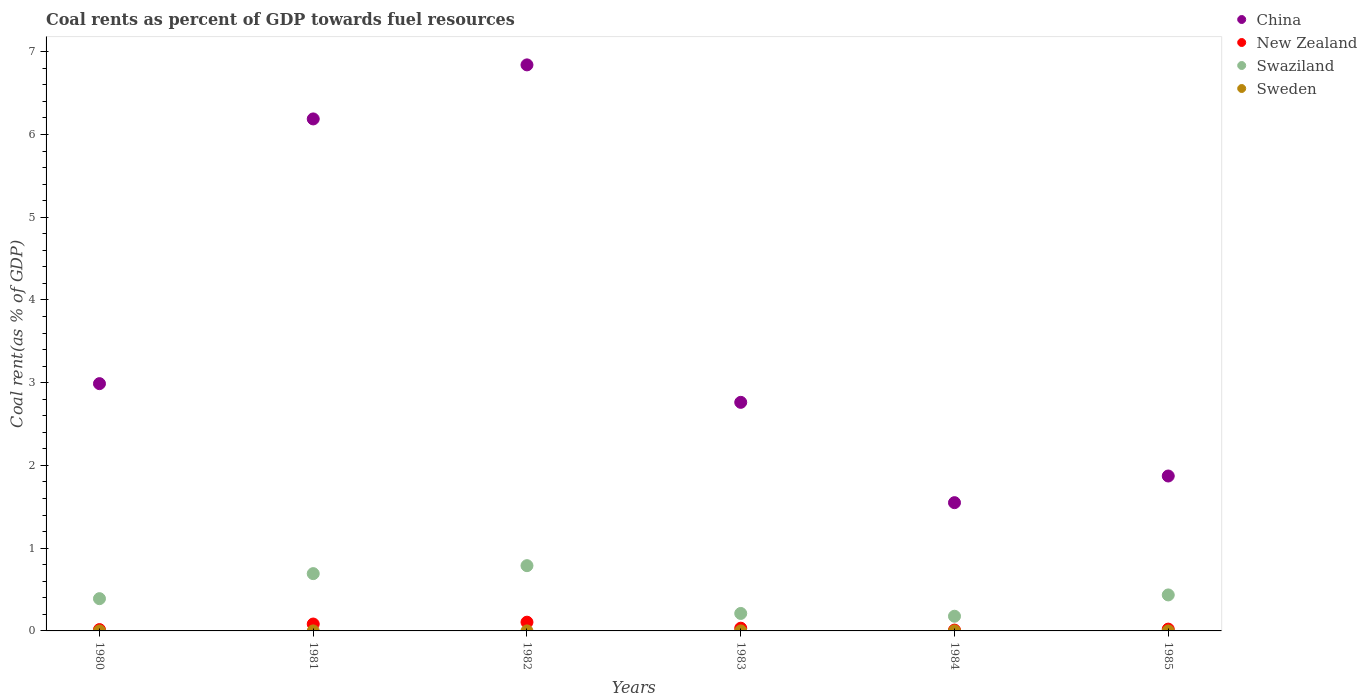Is the number of dotlines equal to the number of legend labels?
Give a very brief answer. Yes. What is the coal rent in Swaziland in 1984?
Your response must be concise. 0.18. Across all years, what is the maximum coal rent in New Zealand?
Your response must be concise. 0.11. Across all years, what is the minimum coal rent in New Zealand?
Keep it short and to the point. 0.01. In which year was the coal rent in New Zealand maximum?
Ensure brevity in your answer.  1982. What is the total coal rent in China in the graph?
Your answer should be compact. 22.2. What is the difference between the coal rent in China in 1983 and that in 1985?
Provide a succinct answer. 0.89. What is the difference between the coal rent in New Zealand in 1984 and the coal rent in Sweden in 1981?
Offer a terse response. 0.01. What is the average coal rent in China per year?
Your answer should be very brief. 3.7. In the year 1984, what is the difference between the coal rent in New Zealand and coal rent in Sweden?
Make the answer very short. 0.01. What is the ratio of the coal rent in Swaziland in 1981 to that in 1983?
Keep it short and to the point. 3.28. What is the difference between the highest and the second highest coal rent in New Zealand?
Ensure brevity in your answer.  0.02. What is the difference between the highest and the lowest coal rent in Swaziland?
Offer a terse response. 0.61. Does the coal rent in Swaziland monotonically increase over the years?
Ensure brevity in your answer.  No. How many years are there in the graph?
Provide a short and direct response. 6. Are the values on the major ticks of Y-axis written in scientific E-notation?
Your answer should be compact. No. Does the graph contain grids?
Offer a very short reply. No. Where does the legend appear in the graph?
Keep it short and to the point. Top right. What is the title of the graph?
Ensure brevity in your answer.  Coal rents as percent of GDP towards fuel resources. Does "United States" appear as one of the legend labels in the graph?
Ensure brevity in your answer.  No. What is the label or title of the Y-axis?
Make the answer very short. Coal rent(as % of GDP). What is the Coal rent(as % of GDP) in China in 1980?
Your answer should be very brief. 2.99. What is the Coal rent(as % of GDP) in New Zealand in 1980?
Provide a succinct answer. 0.02. What is the Coal rent(as % of GDP) of Swaziland in 1980?
Offer a very short reply. 0.39. What is the Coal rent(as % of GDP) in Sweden in 1980?
Give a very brief answer. 3.34719228458372e-5. What is the Coal rent(as % of GDP) in China in 1981?
Your answer should be very brief. 6.19. What is the Coal rent(as % of GDP) of New Zealand in 1981?
Offer a terse response. 0.08. What is the Coal rent(as % of GDP) in Swaziland in 1981?
Offer a very short reply. 0.69. What is the Coal rent(as % of GDP) of Sweden in 1981?
Offer a very short reply. 0. What is the Coal rent(as % of GDP) in China in 1982?
Provide a succinct answer. 6.84. What is the Coal rent(as % of GDP) of New Zealand in 1982?
Keep it short and to the point. 0.11. What is the Coal rent(as % of GDP) of Swaziland in 1982?
Your answer should be compact. 0.79. What is the Coal rent(as % of GDP) in Sweden in 1982?
Your answer should be compact. 0. What is the Coal rent(as % of GDP) in China in 1983?
Give a very brief answer. 2.76. What is the Coal rent(as % of GDP) in New Zealand in 1983?
Give a very brief answer. 0.03. What is the Coal rent(as % of GDP) in Swaziland in 1983?
Give a very brief answer. 0.21. What is the Coal rent(as % of GDP) of Sweden in 1983?
Offer a very short reply. 3.24126709806877e-5. What is the Coal rent(as % of GDP) of China in 1984?
Your response must be concise. 1.55. What is the Coal rent(as % of GDP) in New Zealand in 1984?
Keep it short and to the point. 0.01. What is the Coal rent(as % of GDP) of Swaziland in 1984?
Provide a succinct answer. 0.18. What is the Coal rent(as % of GDP) of Sweden in 1984?
Ensure brevity in your answer.  1.4188022922849e-6. What is the Coal rent(as % of GDP) in China in 1985?
Provide a succinct answer. 1.87. What is the Coal rent(as % of GDP) of New Zealand in 1985?
Provide a short and direct response. 0.02. What is the Coal rent(as % of GDP) in Swaziland in 1985?
Provide a short and direct response. 0.44. What is the Coal rent(as % of GDP) of Sweden in 1985?
Your response must be concise. 1.64898213038946e-5. Across all years, what is the maximum Coal rent(as % of GDP) in China?
Your answer should be compact. 6.84. Across all years, what is the maximum Coal rent(as % of GDP) of New Zealand?
Provide a succinct answer. 0.11. Across all years, what is the maximum Coal rent(as % of GDP) of Swaziland?
Your response must be concise. 0.79. Across all years, what is the maximum Coal rent(as % of GDP) of Sweden?
Ensure brevity in your answer.  0. Across all years, what is the minimum Coal rent(as % of GDP) of China?
Your answer should be very brief. 1.55. Across all years, what is the minimum Coal rent(as % of GDP) of New Zealand?
Your response must be concise. 0.01. Across all years, what is the minimum Coal rent(as % of GDP) in Swaziland?
Offer a very short reply. 0.18. Across all years, what is the minimum Coal rent(as % of GDP) of Sweden?
Your answer should be compact. 1.4188022922849e-6. What is the total Coal rent(as % of GDP) in China in the graph?
Ensure brevity in your answer.  22.2. What is the total Coal rent(as % of GDP) in New Zealand in the graph?
Give a very brief answer. 0.27. What is the total Coal rent(as % of GDP) in Swaziland in the graph?
Your answer should be very brief. 2.69. What is the difference between the Coal rent(as % of GDP) of China in 1980 and that in 1981?
Provide a short and direct response. -3.2. What is the difference between the Coal rent(as % of GDP) of New Zealand in 1980 and that in 1981?
Offer a very short reply. -0.07. What is the difference between the Coal rent(as % of GDP) in Swaziland in 1980 and that in 1981?
Keep it short and to the point. -0.3. What is the difference between the Coal rent(as % of GDP) of Sweden in 1980 and that in 1981?
Offer a terse response. -0. What is the difference between the Coal rent(as % of GDP) in China in 1980 and that in 1982?
Ensure brevity in your answer.  -3.85. What is the difference between the Coal rent(as % of GDP) of New Zealand in 1980 and that in 1982?
Offer a very short reply. -0.09. What is the difference between the Coal rent(as % of GDP) in Swaziland in 1980 and that in 1982?
Offer a terse response. -0.4. What is the difference between the Coal rent(as % of GDP) in Sweden in 1980 and that in 1982?
Your answer should be compact. -0. What is the difference between the Coal rent(as % of GDP) in China in 1980 and that in 1983?
Give a very brief answer. 0.23. What is the difference between the Coal rent(as % of GDP) in New Zealand in 1980 and that in 1983?
Keep it short and to the point. -0.02. What is the difference between the Coal rent(as % of GDP) in Swaziland in 1980 and that in 1983?
Your answer should be compact. 0.18. What is the difference between the Coal rent(as % of GDP) of Sweden in 1980 and that in 1983?
Provide a short and direct response. 0. What is the difference between the Coal rent(as % of GDP) of China in 1980 and that in 1984?
Your answer should be compact. 1.44. What is the difference between the Coal rent(as % of GDP) in New Zealand in 1980 and that in 1984?
Keep it short and to the point. 0.01. What is the difference between the Coal rent(as % of GDP) in Swaziland in 1980 and that in 1984?
Keep it short and to the point. 0.21. What is the difference between the Coal rent(as % of GDP) of Sweden in 1980 and that in 1984?
Ensure brevity in your answer.  0. What is the difference between the Coal rent(as % of GDP) of China in 1980 and that in 1985?
Give a very brief answer. 1.12. What is the difference between the Coal rent(as % of GDP) of New Zealand in 1980 and that in 1985?
Your answer should be compact. -0.01. What is the difference between the Coal rent(as % of GDP) of Swaziland in 1980 and that in 1985?
Ensure brevity in your answer.  -0.05. What is the difference between the Coal rent(as % of GDP) in China in 1981 and that in 1982?
Ensure brevity in your answer.  -0.65. What is the difference between the Coal rent(as % of GDP) in New Zealand in 1981 and that in 1982?
Give a very brief answer. -0.02. What is the difference between the Coal rent(as % of GDP) of Swaziland in 1981 and that in 1982?
Your answer should be compact. -0.1. What is the difference between the Coal rent(as % of GDP) in China in 1981 and that in 1983?
Offer a terse response. 3.43. What is the difference between the Coal rent(as % of GDP) in New Zealand in 1981 and that in 1983?
Offer a terse response. 0.05. What is the difference between the Coal rent(as % of GDP) in Swaziland in 1981 and that in 1983?
Offer a very short reply. 0.48. What is the difference between the Coal rent(as % of GDP) in Sweden in 1981 and that in 1983?
Provide a succinct answer. 0. What is the difference between the Coal rent(as % of GDP) of China in 1981 and that in 1984?
Your response must be concise. 4.64. What is the difference between the Coal rent(as % of GDP) of New Zealand in 1981 and that in 1984?
Give a very brief answer. 0.07. What is the difference between the Coal rent(as % of GDP) of Swaziland in 1981 and that in 1984?
Make the answer very short. 0.52. What is the difference between the Coal rent(as % of GDP) of Sweden in 1981 and that in 1984?
Provide a short and direct response. 0. What is the difference between the Coal rent(as % of GDP) of China in 1981 and that in 1985?
Offer a terse response. 4.32. What is the difference between the Coal rent(as % of GDP) in New Zealand in 1981 and that in 1985?
Your response must be concise. 0.06. What is the difference between the Coal rent(as % of GDP) in Swaziland in 1981 and that in 1985?
Offer a terse response. 0.26. What is the difference between the Coal rent(as % of GDP) of Sweden in 1981 and that in 1985?
Your answer should be compact. 0. What is the difference between the Coal rent(as % of GDP) in China in 1982 and that in 1983?
Provide a succinct answer. 4.08. What is the difference between the Coal rent(as % of GDP) of New Zealand in 1982 and that in 1983?
Keep it short and to the point. 0.07. What is the difference between the Coal rent(as % of GDP) in Swaziland in 1982 and that in 1983?
Offer a terse response. 0.58. What is the difference between the Coal rent(as % of GDP) of China in 1982 and that in 1984?
Your answer should be compact. 5.29. What is the difference between the Coal rent(as % of GDP) in New Zealand in 1982 and that in 1984?
Give a very brief answer. 0.1. What is the difference between the Coal rent(as % of GDP) of Swaziland in 1982 and that in 1984?
Your answer should be very brief. 0.61. What is the difference between the Coal rent(as % of GDP) in China in 1982 and that in 1985?
Give a very brief answer. 4.97. What is the difference between the Coal rent(as % of GDP) of New Zealand in 1982 and that in 1985?
Your answer should be compact. 0.08. What is the difference between the Coal rent(as % of GDP) of Swaziland in 1982 and that in 1985?
Ensure brevity in your answer.  0.35. What is the difference between the Coal rent(as % of GDP) of Sweden in 1982 and that in 1985?
Your answer should be compact. 0. What is the difference between the Coal rent(as % of GDP) in China in 1983 and that in 1984?
Provide a short and direct response. 1.21. What is the difference between the Coal rent(as % of GDP) in New Zealand in 1983 and that in 1984?
Ensure brevity in your answer.  0.02. What is the difference between the Coal rent(as % of GDP) in Swaziland in 1983 and that in 1984?
Provide a short and direct response. 0.03. What is the difference between the Coal rent(as % of GDP) of Sweden in 1983 and that in 1984?
Offer a terse response. 0. What is the difference between the Coal rent(as % of GDP) of China in 1983 and that in 1985?
Give a very brief answer. 0.89. What is the difference between the Coal rent(as % of GDP) of New Zealand in 1983 and that in 1985?
Your answer should be compact. 0.01. What is the difference between the Coal rent(as % of GDP) of Swaziland in 1983 and that in 1985?
Make the answer very short. -0.22. What is the difference between the Coal rent(as % of GDP) of China in 1984 and that in 1985?
Offer a very short reply. -0.32. What is the difference between the Coal rent(as % of GDP) in New Zealand in 1984 and that in 1985?
Your answer should be very brief. -0.01. What is the difference between the Coal rent(as % of GDP) in Swaziland in 1984 and that in 1985?
Give a very brief answer. -0.26. What is the difference between the Coal rent(as % of GDP) in China in 1980 and the Coal rent(as % of GDP) in New Zealand in 1981?
Your answer should be compact. 2.91. What is the difference between the Coal rent(as % of GDP) of China in 1980 and the Coal rent(as % of GDP) of Swaziland in 1981?
Keep it short and to the point. 2.3. What is the difference between the Coal rent(as % of GDP) of China in 1980 and the Coal rent(as % of GDP) of Sweden in 1981?
Provide a short and direct response. 2.99. What is the difference between the Coal rent(as % of GDP) in New Zealand in 1980 and the Coal rent(as % of GDP) in Swaziland in 1981?
Keep it short and to the point. -0.68. What is the difference between the Coal rent(as % of GDP) of New Zealand in 1980 and the Coal rent(as % of GDP) of Sweden in 1981?
Your response must be concise. 0.02. What is the difference between the Coal rent(as % of GDP) in Swaziland in 1980 and the Coal rent(as % of GDP) in Sweden in 1981?
Your answer should be very brief. 0.39. What is the difference between the Coal rent(as % of GDP) of China in 1980 and the Coal rent(as % of GDP) of New Zealand in 1982?
Your response must be concise. 2.88. What is the difference between the Coal rent(as % of GDP) in China in 1980 and the Coal rent(as % of GDP) in Swaziland in 1982?
Your answer should be compact. 2.2. What is the difference between the Coal rent(as % of GDP) in China in 1980 and the Coal rent(as % of GDP) in Sweden in 1982?
Ensure brevity in your answer.  2.99. What is the difference between the Coal rent(as % of GDP) in New Zealand in 1980 and the Coal rent(as % of GDP) in Swaziland in 1982?
Give a very brief answer. -0.77. What is the difference between the Coal rent(as % of GDP) in New Zealand in 1980 and the Coal rent(as % of GDP) in Sweden in 1982?
Your response must be concise. 0.02. What is the difference between the Coal rent(as % of GDP) of Swaziland in 1980 and the Coal rent(as % of GDP) of Sweden in 1982?
Your response must be concise. 0.39. What is the difference between the Coal rent(as % of GDP) in China in 1980 and the Coal rent(as % of GDP) in New Zealand in 1983?
Provide a short and direct response. 2.96. What is the difference between the Coal rent(as % of GDP) of China in 1980 and the Coal rent(as % of GDP) of Swaziland in 1983?
Your answer should be compact. 2.78. What is the difference between the Coal rent(as % of GDP) of China in 1980 and the Coal rent(as % of GDP) of Sweden in 1983?
Make the answer very short. 2.99. What is the difference between the Coal rent(as % of GDP) of New Zealand in 1980 and the Coal rent(as % of GDP) of Swaziland in 1983?
Ensure brevity in your answer.  -0.2. What is the difference between the Coal rent(as % of GDP) in New Zealand in 1980 and the Coal rent(as % of GDP) in Sweden in 1983?
Your answer should be compact. 0.02. What is the difference between the Coal rent(as % of GDP) in Swaziland in 1980 and the Coal rent(as % of GDP) in Sweden in 1983?
Your response must be concise. 0.39. What is the difference between the Coal rent(as % of GDP) in China in 1980 and the Coal rent(as % of GDP) in New Zealand in 1984?
Make the answer very short. 2.98. What is the difference between the Coal rent(as % of GDP) of China in 1980 and the Coal rent(as % of GDP) of Swaziland in 1984?
Your response must be concise. 2.81. What is the difference between the Coal rent(as % of GDP) of China in 1980 and the Coal rent(as % of GDP) of Sweden in 1984?
Give a very brief answer. 2.99. What is the difference between the Coal rent(as % of GDP) in New Zealand in 1980 and the Coal rent(as % of GDP) in Swaziland in 1984?
Your answer should be compact. -0.16. What is the difference between the Coal rent(as % of GDP) in New Zealand in 1980 and the Coal rent(as % of GDP) in Sweden in 1984?
Give a very brief answer. 0.02. What is the difference between the Coal rent(as % of GDP) of Swaziland in 1980 and the Coal rent(as % of GDP) of Sweden in 1984?
Provide a succinct answer. 0.39. What is the difference between the Coal rent(as % of GDP) in China in 1980 and the Coal rent(as % of GDP) in New Zealand in 1985?
Ensure brevity in your answer.  2.97. What is the difference between the Coal rent(as % of GDP) in China in 1980 and the Coal rent(as % of GDP) in Swaziland in 1985?
Your response must be concise. 2.55. What is the difference between the Coal rent(as % of GDP) of China in 1980 and the Coal rent(as % of GDP) of Sweden in 1985?
Offer a terse response. 2.99. What is the difference between the Coal rent(as % of GDP) of New Zealand in 1980 and the Coal rent(as % of GDP) of Swaziland in 1985?
Keep it short and to the point. -0.42. What is the difference between the Coal rent(as % of GDP) of New Zealand in 1980 and the Coal rent(as % of GDP) of Sweden in 1985?
Keep it short and to the point. 0.02. What is the difference between the Coal rent(as % of GDP) of Swaziland in 1980 and the Coal rent(as % of GDP) of Sweden in 1985?
Give a very brief answer. 0.39. What is the difference between the Coal rent(as % of GDP) in China in 1981 and the Coal rent(as % of GDP) in New Zealand in 1982?
Make the answer very short. 6.08. What is the difference between the Coal rent(as % of GDP) in China in 1981 and the Coal rent(as % of GDP) in Swaziland in 1982?
Offer a very short reply. 5.4. What is the difference between the Coal rent(as % of GDP) of China in 1981 and the Coal rent(as % of GDP) of Sweden in 1982?
Give a very brief answer. 6.19. What is the difference between the Coal rent(as % of GDP) of New Zealand in 1981 and the Coal rent(as % of GDP) of Swaziland in 1982?
Your response must be concise. -0.71. What is the difference between the Coal rent(as % of GDP) in New Zealand in 1981 and the Coal rent(as % of GDP) in Sweden in 1982?
Make the answer very short. 0.08. What is the difference between the Coal rent(as % of GDP) in Swaziland in 1981 and the Coal rent(as % of GDP) in Sweden in 1982?
Make the answer very short. 0.69. What is the difference between the Coal rent(as % of GDP) of China in 1981 and the Coal rent(as % of GDP) of New Zealand in 1983?
Your response must be concise. 6.15. What is the difference between the Coal rent(as % of GDP) of China in 1981 and the Coal rent(as % of GDP) of Swaziland in 1983?
Ensure brevity in your answer.  5.98. What is the difference between the Coal rent(as % of GDP) in China in 1981 and the Coal rent(as % of GDP) in Sweden in 1983?
Ensure brevity in your answer.  6.19. What is the difference between the Coal rent(as % of GDP) in New Zealand in 1981 and the Coal rent(as % of GDP) in Swaziland in 1983?
Offer a terse response. -0.13. What is the difference between the Coal rent(as % of GDP) of New Zealand in 1981 and the Coal rent(as % of GDP) of Sweden in 1983?
Your answer should be compact. 0.08. What is the difference between the Coal rent(as % of GDP) of Swaziland in 1981 and the Coal rent(as % of GDP) of Sweden in 1983?
Keep it short and to the point. 0.69. What is the difference between the Coal rent(as % of GDP) in China in 1981 and the Coal rent(as % of GDP) in New Zealand in 1984?
Keep it short and to the point. 6.18. What is the difference between the Coal rent(as % of GDP) of China in 1981 and the Coal rent(as % of GDP) of Swaziland in 1984?
Provide a short and direct response. 6.01. What is the difference between the Coal rent(as % of GDP) of China in 1981 and the Coal rent(as % of GDP) of Sweden in 1984?
Ensure brevity in your answer.  6.19. What is the difference between the Coal rent(as % of GDP) in New Zealand in 1981 and the Coal rent(as % of GDP) in Swaziland in 1984?
Make the answer very short. -0.09. What is the difference between the Coal rent(as % of GDP) in New Zealand in 1981 and the Coal rent(as % of GDP) in Sweden in 1984?
Provide a succinct answer. 0.08. What is the difference between the Coal rent(as % of GDP) in Swaziland in 1981 and the Coal rent(as % of GDP) in Sweden in 1984?
Ensure brevity in your answer.  0.69. What is the difference between the Coal rent(as % of GDP) in China in 1981 and the Coal rent(as % of GDP) in New Zealand in 1985?
Your answer should be compact. 6.17. What is the difference between the Coal rent(as % of GDP) of China in 1981 and the Coal rent(as % of GDP) of Swaziland in 1985?
Provide a succinct answer. 5.75. What is the difference between the Coal rent(as % of GDP) in China in 1981 and the Coal rent(as % of GDP) in Sweden in 1985?
Your answer should be very brief. 6.19. What is the difference between the Coal rent(as % of GDP) of New Zealand in 1981 and the Coal rent(as % of GDP) of Swaziland in 1985?
Your response must be concise. -0.35. What is the difference between the Coal rent(as % of GDP) in New Zealand in 1981 and the Coal rent(as % of GDP) in Sweden in 1985?
Ensure brevity in your answer.  0.08. What is the difference between the Coal rent(as % of GDP) in Swaziland in 1981 and the Coal rent(as % of GDP) in Sweden in 1985?
Provide a short and direct response. 0.69. What is the difference between the Coal rent(as % of GDP) of China in 1982 and the Coal rent(as % of GDP) of New Zealand in 1983?
Provide a short and direct response. 6.81. What is the difference between the Coal rent(as % of GDP) of China in 1982 and the Coal rent(as % of GDP) of Swaziland in 1983?
Provide a succinct answer. 6.63. What is the difference between the Coal rent(as % of GDP) in China in 1982 and the Coal rent(as % of GDP) in Sweden in 1983?
Your response must be concise. 6.84. What is the difference between the Coal rent(as % of GDP) in New Zealand in 1982 and the Coal rent(as % of GDP) in Swaziland in 1983?
Ensure brevity in your answer.  -0.11. What is the difference between the Coal rent(as % of GDP) of New Zealand in 1982 and the Coal rent(as % of GDP) of Sweden in 1983?
Your response must be concise. 0.11. What is the difference between the Coal rent(as % of GDP) of Swaziland in 1982 and the Coal rent(as % of GDP) of Sweden in 1983?
Your response must be concise. 0.79. What is the difference between the Coal rent(as % of GDP) in China in 1982 and the Coal rent(as % of GDP) in New Zealand in 1984?
Offer a very short reply. 6.83. What is the difference between the Coal rent(as % of GDP) of China in 1982 and the Coal rent(as % of GDP) of Swaziland in 1984?
Keep it short and to the point. 6.66. What is the difference between the Coal rent(as % of GDP) of China in 1982 and the Coal rent(as % of GDP) of Sweden in 1984?
Give a very brief answer. 6.84. What is the difference between the Coal rent(as % of GDP) in New Zealand in 1982 and the Coal rent(as % of GDP) in Swaziland in 1984?
Your answer should be compact. -0.07. What is the difference between the Coal rent(as % of GDP) in New Zealand in 1982 and the Coal rent(as % of GDP) in Sweden in 1984?
Your response must be concise. 0.11. What is the difference between the Coal rent(as % of GDP) in Swaziland in 1982 and the Coal rent(as % of GDP) in Sweden in 1984?
Provide a succinct answer. 0.79. What is the difference between the Coal rent(as % of GDP) of China in 1982 and the Coal rent(as % of GDP) of New Zealand in 1985?
Your answer should be compact. 6.82. What is the difference between the Coal rent(as % of GDP) in China in 1982 and the Coal rent(as % of GDP) in Swaziland in 1985?
Make the answer very short. 6.41. What is the difference between the Coal rent(as % of GDP) in China in 1982 and the Coal rent(as % of GDP) in Sweden in 1985?
Provide a succinct answer. 6.84. What is the difference between the Coal rent(as % of GDP) in New Zealand in 1982 and the Coal rent(as % of GDP) in Swaziland in 1985?
Your answer should be compact. -0.33. What is the difference between the Coal rent(as % of GDP) of New Zealand in 1982 and the Coal rent(as % of GDP) of Sweden in 1985?
Your answer should be compact. 0.11. What is the difference between the Coal rent(as % of GDP) in Swaziland in 1982 and the Coal rent(as % of GDP) in Sweden in 1985?
Offer a terse response. 0.79. What is the difference between the Coal rent(as % of GDP) in China in 1983 and the Coal rent(as % of GDP) in New Zealand in 1984?
Keep it short and to the point. 2.75. What is the difference between the Coal rent(as % of GDP) in China in 1983 and the Coal rent(as % of GDP) in Swaziland in 1984?
Give a very brief answer. 2.59. What is the difference between the Coal rent(as % of GDP) of China in 1983 and the Coal rent(as % of GDP) of Sweden in 1984?
Offer a very short reply. 2.76. What is the difference between the Coal rent(as % of GDP) in New Zealand in 1983 and the Coal rent(as % of GDP) in Swaziland in 1984?
Offer a terse response. -0.14. What is the difference between the Coal rent(as % of GDP) in New Zealand in 1983 and the Coal rent(as % of GDP) in Sweden in 1984?
Offer a very short reply. 0.03. What is the difference between the Coal rent(as % of GDP) in Swaziland in 1983 and the Coal rent(as % of GDP) in Sweden in 1984?
Offer a very short reply. 0.21. What is the difference between the Coal rent(as % of GDP) of China in 1983 and the Coal rent(as % of GDP) of New Zealand in 1985?
Make the answer very short. 2.74. What is the difference between the Coal rent(as % of GDP) in China in 1983 and the Coal rent(as % of GDP) in Swaziland in 1985?
Offer a very short reply. 2.33. What is the difference between the Coal rent(as % of GDP) of China in 1983 and the Coal rent(as % of GDP) of Sweden in 1985?
Offer a terse response. 2.76. What is the difference between the Coal rent(as % of GDP) of New Zealand in 1983 and the Coal rent(as % of GDP) of Swaziland in 1985?
Ensure brevity in your answer.  -0.4. What is the difference between the Coal rent(as % of GDP) in New Zealand in 1983 and the Coal rent(as % of GDP) in Sweden in 1985?
Provide a short and direct response. 0.03. What is the difference between the Coal rent(as % of GDP) of Swaziland in 1983 and the Coal rent(as % of GDP) of Sweden in 1985?
Your answer should be compact. 0.21. What is the difference between the Coal rent(as % of GDP) in China in 1984 and the Coal rent(as % of GDP) in New Zealand in 1985?
Ensure brevity in your answer.  1.53. What is the difference between the Coal rent(as % of GDP) of China in 1984 and the Coal rent(as % of GDP) of Swaziland in 1985?
Give a very brief answer. 1.12. What is the difference between the Coal rent(as % of GDP) in China in 1984 and the Coal rent(as % of GDP) in Sweden in 1985?
Your response must be concise. 1.55. What is the difference between the Coal rent(as % of GDP) in New Zealand in 1984 and the Coal rent(as % of GDP) in Swaziland in 1985?
Your response must be concise. -0.42. What is the difference between the Coal rent(as % of GDP) of New Zealand in 1984 and the Coal rent(as % of GDP) of Sweden in 1985?
Offer a very short reply. 0.01. What is the difference between the Coal rent(as % of GDP) of Swaziland in 1984 and the Coal rent(as % of GDP) of Sweden in 1985?
Keep it short and to the point. 0.18. What is the average Coal rent(as % of GDP) in China per year?
Your response must be concise. 3.7. What is the average Coal rent(as % of GDP) in New Zealand per year?
Provide a short and direct response. 0.04. What is the average Coal rent(as % of GDP) in Swaziland per year?
Keep it short and to the point. 0.45. What is the average Coal rent(as % of GDP) in Sweden per year?
Ensure brevity in your answer.  0. In the year 1980, what is the difference between the Coal rent(as % of GDP) in China and Coal rent(as % of GDP) in New Zealand?
Offer a terse response. 2.97. In the year 1980, what is the difference between the Coal rent(as % of GDP) of China and Coal rent(as % of GDP) of Swaziland?
Your answer should be compact. 2.6. In the year 1980, what is the difference between the Coal rent(as % of GDP) of China and Coal rent(as % of GDP) of Sweden?
Provide a short and direct response. 2.99. In the year 1980, what is the difference between the Coal rent(as % of GDP) in New Zealand and Coal rent(as % of GDP) in Swaziland?
Make the answer very short. -0.37. In the year 1980, what is the difference between the Coal rent(as % of GDP) of New Zealand and Coal rent(as % of GDP) of Sweden?
Make the answer very short. 0.02. In the year 1980, what is the difference between the Coal rent(as % of GDP) in Swaziland and Coal rent(as % of GDP) in Sweden?
Your answer should be very brief. 0.39. In the year 1981, what is the difference between the Coal rent(as % of GDP) in China and Coal rent(as % of GDP) in New Zealand?
Your response must be concise. 6.1. In the year 1981, what is the difference between the Coal rent(as % of GDP) in China and Coal rent(as % of GDP) in Swaziland?
Give a very brief answer. 5.5. In the year 1981, what is the difference between the Coal rent(as % of GDP) in China and Coal rent(as % of GDP) in Sweden?
Offer a terse response. 6.19. In the year 1981, what is the difference between the Coal rent(as % of GDP) of New Zealand and Coal rent(as % of GDP) of Swaziland?
Keep it short and to the point. -0.61. In the year 1981, what is the difference between the Coal rent(as % of GDP) of New Zealand and Coal rent(as % of GDP) of Sweden?
Offer a very short reply. 0.08. In the year 1981, what is the difference between the Coal rent(as % of GDP) of Swaziland and Coal rent(as % of GDP) of Sweden?
Keep it short and to the point. 0.69. In the year 1982, what is the difference between the Coal rent(as % of GDP) of China and Coal rent(as % of GDP) of New Zealand?
Keep it short and to the point. 6.74. In the year 1982, what is the difference between the Coal rent(as % of GDP) of China and Coal rent(as % of GDP) of Swaziland?
Offer a terse response. 6.05. In the year 1982, what is the difference between the Coal rent(as % of GDP) of China and Coal rent(as % of GDP) of Sweden?
Make the answer very short. 6.84. In the year 1982, what is the difference between the Coal rent(as % of GDP) of New Zealand and Coal rent(as % of GDP) of Swaziland?
Keep it short and to the point. -0.68. In the year 1982, what is the difference between the Coal rent(as % of GDP) of New Zealand and Coal rent(as % of GDP) of Sweden?
Your answer should be very brief. 0.11. In the year 1982, what is the difference between the Coal rent(as % of GDP) in Swaziland and Coal rent(as % of GDP) in Sweden?
Ensure brevity in your answer.  0.79. In the year 1983, what is the difference between the Coal rent(as % of GDP) in China and Coal rent(as % of GDP) in New Zealand?
Offer a terse response. 2.73. In the year 1983, what is the difference between the Coal rent(as % of GDP) in China and Coal rent(as % of GDP) in Swaziland?
Your answer should be very brief. 2.55. In the year 1983, what is the difference between the Coal rent(as % of GDP) of China and Coal rent(as % of GDP) of Sweden?
Offer a terse response. 2.76. In the year 1983, what is the difference between the Coal rent(as % of GDP) of New Zealand and Coal rent(as % of GDP) of Swaziland?
Your response must be concise. -0.18. In the year 1983, what is the difference between the Coal rent(as % of GDP) of New Zealand and Coal rent(as % of GDP) of Sweden?
Your response must be concise. 0.03. In the year 1983, what is the difference between the Coal rent(as % of GDP) of Swaziland and Coal rent(as % of GDP) of Sweden?
Provide a succinct answer. 0.21. In the year 1984, what is the difference between the Coal rent(as % of GDP) of China and Coal rent(as % of GDP) of New Zealand?
Provide a short and direct response. 1.54. In the year 1984, what is the difference between the Coal rent(as % of GDP) of China and Coal rent(as % of GDP) of Swaziland?
Offer a very short reply. 1.37. In the year 1984, what is the difference between the Coal rent(as % of GDP) of China and Coal rent(as % of GDP) of Sweden?
Ensure brevity in your answer.  1.55. In the year 1984, what is the difference between the Coal rent(as % of GDP) in New Zealand and Coal rent(as % of GDP) in Swaziland?
Give a very brief answer. -0.17. In the year 1984, what is the difference between the Coal rent(as % of GDP) of New Zealand and Coal rent(as % of GDP) of Sweden?
Provide a short and direct response. 0.01. In the year 1984, what is the difference between the Coal rent(as % of GDP) of Swaziland and Coal rent(as % of GDP) of Sweden?
Your answer should be compact. 0.18. In the year 1985, what is the difference between the Coal rent(as % of GDP) of China and Coal rent(as % of GDP) of New Zealand?
Offer a terse response. 1.85. In the year 1985, what is the difference between the Coal rent(as % of GDP) of China and Coal rent(as % of GDP) of Swaziland?
Offer a terse response. 1.44. In the year 1985, what is the difference between the Coal rent(as % of GDP) in China and Coal rent(as % of GDP) in Sweden?
Your answer should be very brief. 1.87. In the year 1985, what is the difference between the Coal rent(as % of GDP) in New Zealand and Coal rent(as % of GDP) in Swaziland?
Your answer should be compact. -0.41. In the year 1985, what is the difference between the Coal rent(as % of GDP) of New Zealand and Coal rent(as % of GDP) of Sweden?
Offer a terse response. 0.02. In the year 1985, what is the difference between the Coal rent(as % of GDP) of Swaziland and Coal rent(as % of GDP) of Sweden?
Your answer should be compact. 0.43. What is the ratio of the Coal rent(as % of GDP) of China in 1980 to that in 1981?
Keep it short and to the point. 0.48. What is the ratio of the Coal rent(as % of GDP) in New Zealand in 1980 to that in 1981?
Ensure brevity in your answer.  0.19. What is the ratio of the Coal rent(as % of GDP) of Swaziland in 1980 to that in 1981?
Your answer should be compact. 0.56. What is the ratio of the Coal rent(as % of GDP) in Sweden in 1980 to that in 1981?
Your answer should be compact. 0.16. What is the ratio of the Coal rent(as % of GDP) in China in 1980 to that in 1982?
Provide a short and direct response. 0.44. What is the ratio of the Coal rent(as % of GDP) of New Zealand in 1980 to that in 1982?
Give a very brief answer. 0.15. What is the ratio of the Coal rent(as % of GDP) in Swaziland in 1980 to that in 1982?
Your answer should be very brief. 0.49. What is the ratio of the Coal rent(as % of GDP) in Sweden in 1980 to that in 1982?
Make the answer very short. 0.27. What is the ratio of the Coal rent(as % of GDP) in China in 1980 to that in 1983?
Keep it short and to the point. 1.08. What is the ratio of the Coal rent(as % of GDP) of New Zealand in 1980 to that in 1983?
Keep it short and to the point. 0.49. What is the ratio of the Coal rent(as % of GDP) of Swaziland in 1980 to that in 1983?
Offer a terse response. 1.85. What is the ratio of the Coal rent(as % of GDP) of Sweden in 1980 to that in 1983?
Make the answer very short. 1.03. What is the ratio of the Coal rent(as % of GDP) in China in 1980 to that in 1984?
Your answer should be compact. 1.93. What is the ratio of the Coal rent(as % of GDP) of New Zealand in 1980 to that in 1984?
Your response must be concise. 1.6. What is the ratio of the Coal rent(as % of GDP) in Swaziland in 1980 to that in 1984?
Your response must be concise. 2.2. What is the ratio of the Coal rent(as % of GDP) in Sweden in 1980 to that in 1984?
Offer a very short reply. 23.59. What is the ratio of the Coal rent(as % of GDP) of China in 1980 to that in 1985?
Keep it short and to the point. 1.6. What is the ratio of the Coal rent(as % of GDP) of New Zealand in 1980 to that in 1985?
Ensure brevity in your answer.  0.74. What is the ratio of the Coal rent(as % of GDP) in Swaziland in 1980 to that in 1985?
Give a very brief answer. 0.9. What is the ratio of the Coal rent(as % of GDP) of Sweden in 1980 to that in 1985?
Keep it short and to the point. 2.03. What is the ratio of the Coal rent(as % of GDP) of China in 1981 to that in 1982?
Provide a short and direct response. 0.9. What is the ratio of the Coal rent(as % of GDP) of New Zealand in 1981 to that in 1982?
Keep it short and to the point. 0.79. What is the ratio of the Coal rent(as % of GDP) of Swaziland in 1981 to that in 1982?
Your response must be concise. 0.88. What is the ratio of the Coal rent(as % of GDP) in Sweden in 1981 to that in 1982?
Your response must be concise. 1.7. What is the ratio of the Coal rent(as % of GDP) in China in 1981 to that in 1983?
Your answer should be very brief. 2.24. What is the ratio of the Coal rent(as % of GDP) in New Zealand in 1981 to that in 1983?
Make the answer very short. 2.53. What is the ratio of the Coal rent(as % of GDP) of Swaziland in 1981 to that in 1983?
Your answer should be compact. 3.28. What is the ratio of the Coal rent(as % of GDP) in Sweden in 1981 to that in 1983?
Ensure brevity in your answer.  6.39. What is the ratio of the Coal rent(as % of GDP) of China in 1981 to that in 1984?
Make the answer very short. 3.99. What is the ratio of the Coal rent(as % of GDP) in New Zealand in 1981 to that in 1984?
Provide a succinct answer. 8.31. What is the ratio of the Coal rent(as % of GDP) in Swaziland in 1981 to that in 1984?
Your answer should be compact. 3.9. What is the ratio of the Coal rent(as % of GDP) in Sweden in 1981 to that in 1984?
Offer a terse response. 145.99. What is the ratio of the Coal rent(as % of GDP) of China in 1981 to that in 1985?
Offer a very short reply. 3.31. What is the ratio of the Coal rent(as % of GDP) in New Zealand in 1981 to that in 1985?
Give a very brief answer. 3.83. What is the ratio of the Coal rent(as % of GDP) in Swaziland in 1981 to that in 1985?
Keep it short and to the point. 1.59. What is the ratio of the Coal rent(as % of GDP) of Sweden in 1981 to that in 1985?
Provide a succinct answer. 12.56. What is the ratio of the Coal rent(as % of GDP) of China in 1982 to that in 1983?
Provide a short and direct response. 2.48. What is the ratio of the Coal rent(as % of GDP) of New Zealand in 1982 to that in 1983?
Provide a short and direct response. 3.21. What is the ratio of the Coal rent(as % of GDP) in Swaziland in 1982 to that in 1983?
Your answer should be compact. 3.74. What is the ratio of the Coal rent(as % of GDP) in Sweden in 1982 to that in 1983?
Offer a terse response. 3.76. What is the ratio of the Coal rent(as % of GDP) of China in 1982 to that in 1984?
Your answer should be compact. 4.41. What is the ratio of the Coal rent(as % of GDP) of New Zealand in 1982 to that in 1984?
Provide a short and direct response. 10.54. What is the ratio of the Coal rent(as % of GDP) in Swaziland in 1982 to that in 1984?
Give a very brief answer. 4.44. What is the ratio of the Coal rent(as % of GDP) of Sweden in 1982 to that in 1984?
Your answer should be very brief. 85.94. What is the ratio of the Coal rent(as % of GDP) of China in 1982 to that in 1985?
Make the answer very short. 3.65. What is the ratio of the Coal rent(as % of GDP) of New Zealand in 1982 to that in 1985?
Make the answer very short. 4.86. What is the ratio of the Coal rent(as % of GDP) of Swaziland in 1982 to that in 1985?
Keep it short and to the point. 1.81. What is the ratio of the Coal rent(as % of GDP) in Sweden in 1982 to that in 1985?
Make the answer very short. 7.39. What is the ratio of the Coal rent(as % of GDP) in China in 1983 to that in 1984?
Your response must be concise. 1.78. What is the ratio of the Coal rent(as % of GDP) of New Zealand in 1983 to that in 1984?
Give a very brief answer. 3.28. What is the ratio of the Coal rent(as % of GDP) of Swaziland in 1983 to that in 1984?
Make the answer very short. 1.19. What is the ratio of the Coal rent(as % of GDP) of Sweden in 1983 to that in 1984?
Keep it short and to the point. 22.85. What is the ratio of the Coal rent(as % of GDP) in China in 1983 to that in 1985?
Make the answer very short. 1.48. What is the ratio of the Coal rent(as % of GDP) in New Zealand in 1983 to that in 1985?
Make the answer very short. 1.51. What is the ratio of the Coal rent(as % of GDP) of Swaziland in 1983 to that in 1985?
Make the answer very short. 0.49. What is the ratio of the Coal rent(as % of GDP) of Sweden in 1983 to that in 1985?
Offer a terse response. 1.97. What is the ratio of the Coal rent(as % of GDP) of China in 1984 to that in 1985?
Provide a succinct answer. 0.83. What is the ratio of the Coal rent(as % of GDP) of New Zealand in 1984 to that in 1985?
Provide a short and direct response. 0.46. What is the ratio of the Coal rent(as % of GDP) of Swaziland in 1984 to that in 1985?
Make the answer very short. 0.41. What is the ratio of the Coal rent(as % of GDP) in Sweden in 1984 to that in 1985?
Your answer should be very brief. 0.09. What is the difference between the highest and the second highest Coal rent(as % of GDP) of China?
Your answer should be very brief. 0.65. What is the difference between the highest and the second highest Coal rent(as % of GDP) in New Zealand?
Provide a succinct answer. 0.02. What is the difference between the highest and the second highest Coal rent(as % of GDP) in Swaziland?
Offer a very short reply. 0.1. What is the difference between the highest and the lowest Coal rent(as % of GDP) in China?
Your response must be concise. 5.29. What is the difference between the highest and the lowest Coal rent(as % of GDP) in New Zealand?
Offer a very short reply. 0.1. What is the difference between the highest and the lowest Coal rent(as % of GDP) in Swaziland?
Give a very brief answer. 0.61. 